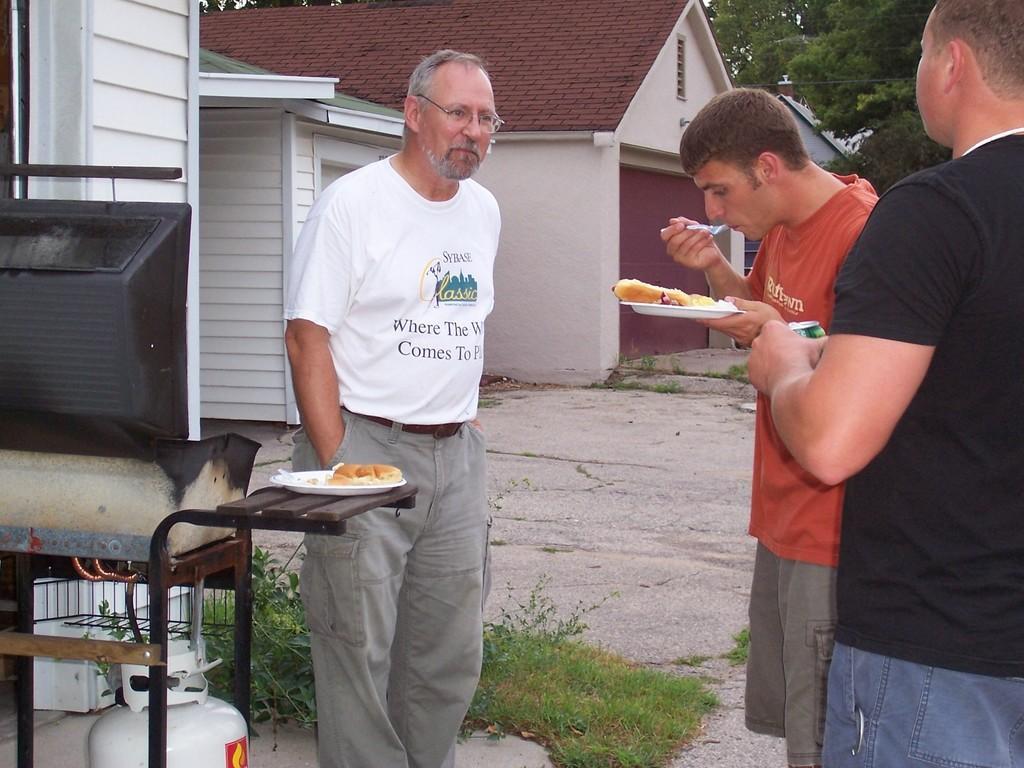Can you describe this image briefly? In this picture there is a man who is wearing white t-shirt, spectacle and short. He is standing near to the table. On the table we can see a white plate, bread and tissue paper. On the right there is a man who is wearing black dress and jeans. He is holding coke can. Beside him we can see another man who is wearing t-shirt and short. He is holding plate and spoon. In the background we can see building. On the top right we can see trees. Here we can see shelter. On the bottom we can see grass. Here it's a sky. 